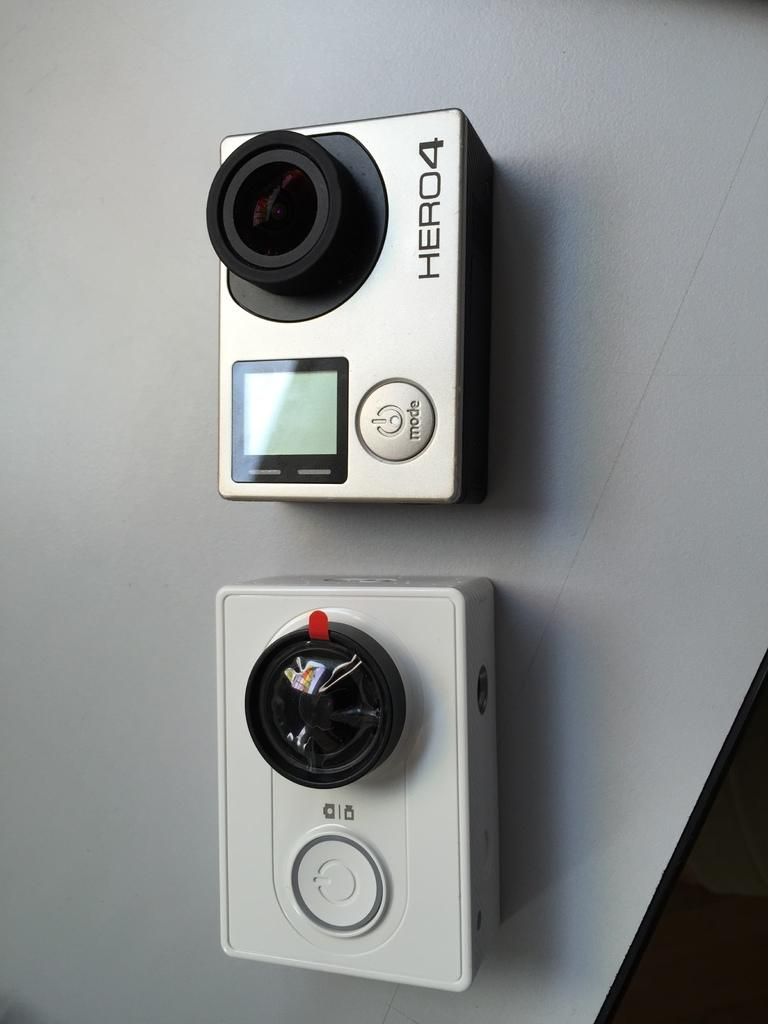How many cameras are visible in the image? There are two cameras in the image. What type of lace is being used to secure the cameras in the image? There is no lace present in the image; the cameras are not secured with any visible lace. 